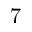Convert formula to latex. <formula><loc_0><loc_0><loc_500><loc_500>7</formula> 